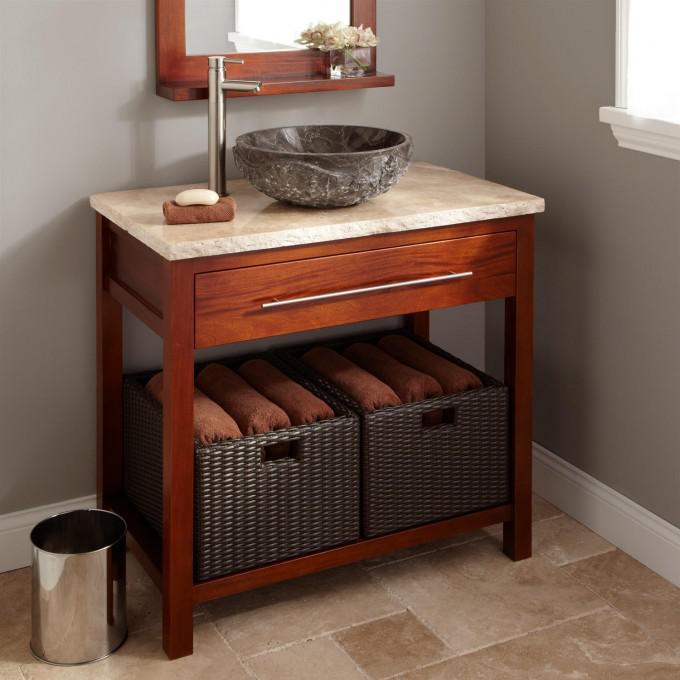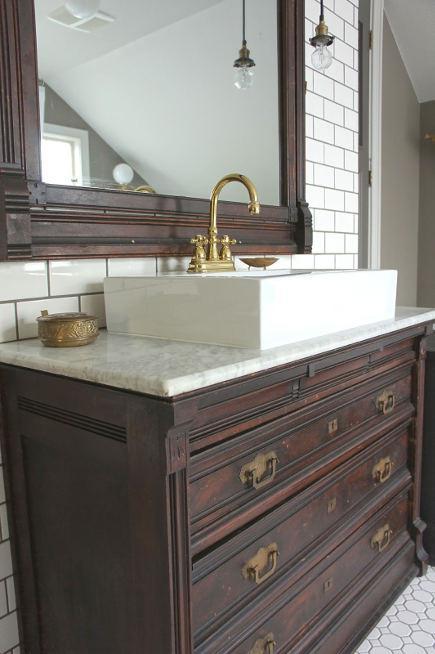The first image is the image on the left, the second image is the image on the right. Assess this claim about the two images: "Each image shows a dark metal sewing machine base used as part of a sink vanity, and at least one image features a wood grain counter that holds the sink.". Correct or not? Answer yes or no. No. The first image is the image on the left, the second image is the image on the right. Evaluate the accuracy of this statement regarding the images: "Both images show a sewing table with a black metal base converted into a bathroom sink.". Is it true? Answer yes or no. No. 